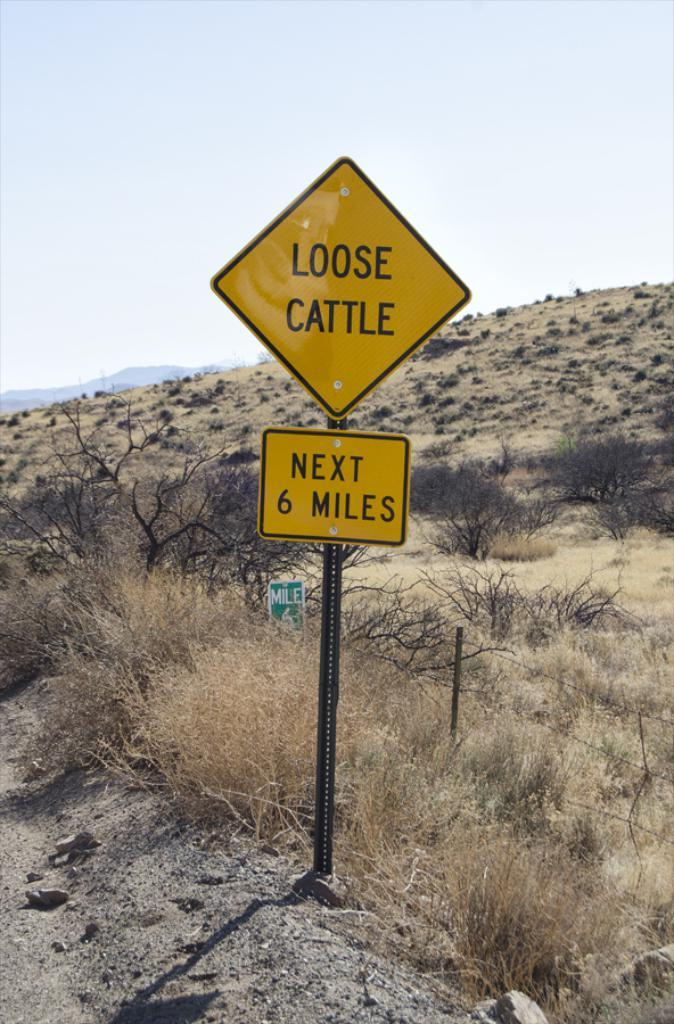<image>
Write a terse but informative summary of the picture. A yellow sign next to a dirt road that says LOOSE CATTLE NEXT 6 MILES 